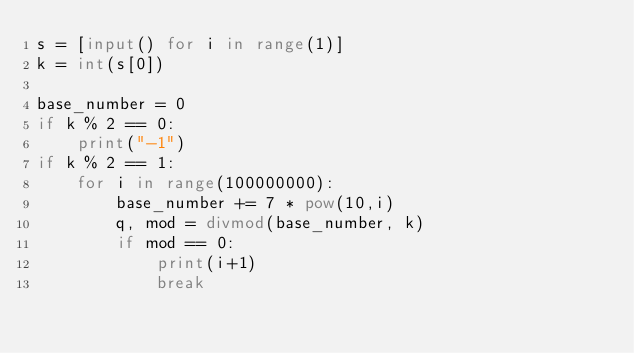<code> <loc_0><loc_0><loc_500><loc_500><_Python_>s = [input() for i in range(1)] 
k = int(s[0])

base_number = 0
if k % 2 == 0:
    print("-1")
if k % 2 == 1:
    for i in range(100000000):
        base_number += 7 * pow(10,i)
        q, mod = divmod(base_number, k)
        if mod == 0:
            print(i+1)
            break</code> 